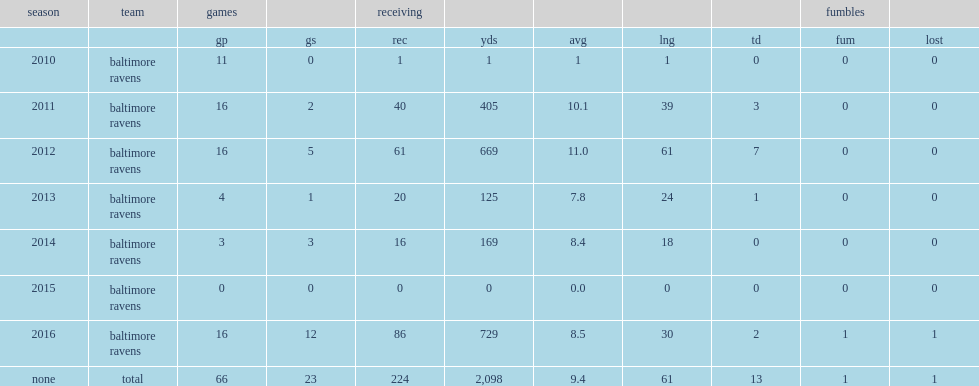How many receptions did dennis pitta get in 2016? 86.0. Parse the table in full. {'header': ['season', 'team', 'games', '', 'receiving', '', '', '', '', 'fumbles', ''], 'rows': [['', '', 'gp', 'gs', 'rec', 'yds', 'avg', 'lng', 'td', 'fum', 'lost'], ['2010', 'baltimore ravens', '11', '0', '1', '1', '1', '1', '0', '0', '0'], ['2011', 'baltimore ravens', '16', '2', '40', '405', '10.1', '39', '3', '0', '0'], ['2012', 'baltimore ravens', '16', '5', '61', '669', '11.0', '61', '7', '0', '0'], ['2013', 'baltimore ravens', '4', '1', '20', '125', '7.8', '24', '1', '0', '0'], ['2014', 'baltimore ravens', '3', '3', '16', '169', '8.4', '18', '0', '0', '0'], ['2015', 'baltimore ravens', '0', '0', '0', '0', '0.0', '0', '0', '0', '0'], ['2016', 'baltimore ravens', '16', '12', '86', '729', '8.5', '30', '2', '1', '1'], ['none', 'total', '66', '23', '224', '2,098', '9.4', '61', '13', '1', '1']]} 